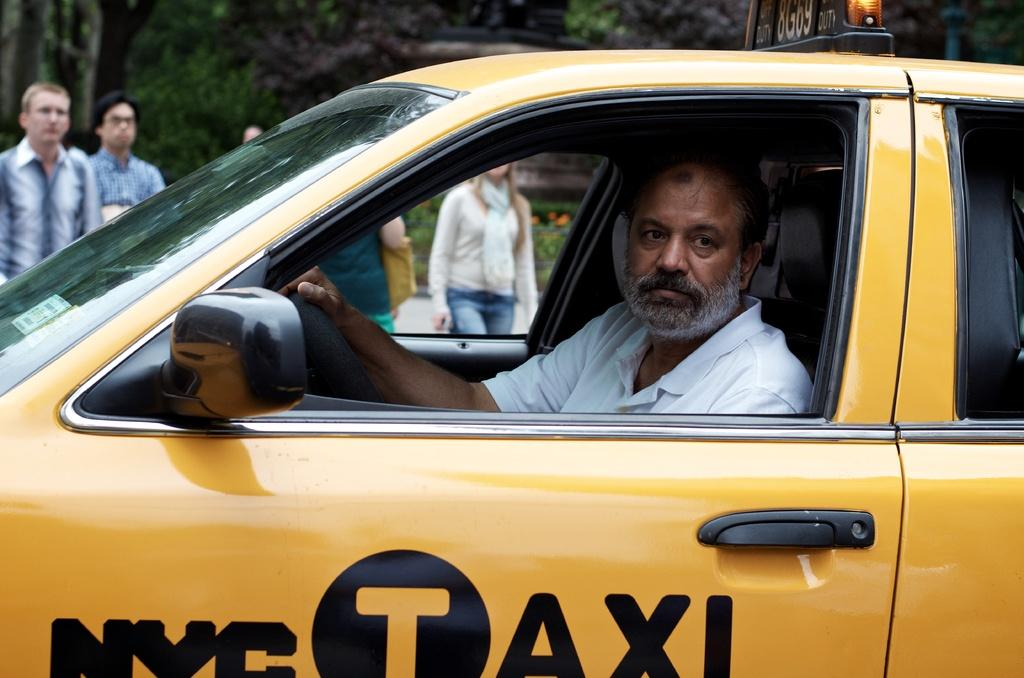<image>
Render a clear and concise summary of the photo. A man with two tones of facial hair is driving a NYC Taxi. 